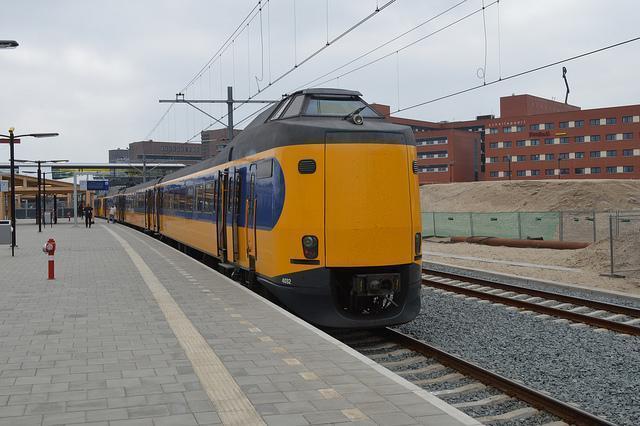What substance can be obtained from the red object?
From the following four choices, select the correct answer to address the question.
Options: Juice, oil, water, fire. Water. 